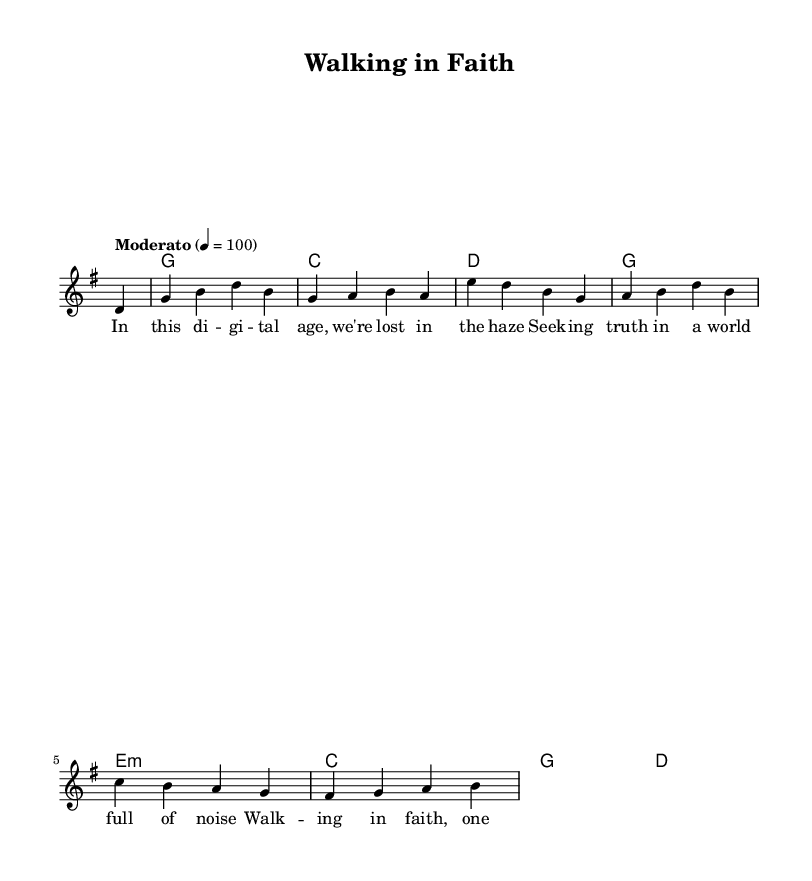What is the key signature of this music? The key signature is G major, which has one sharp (F#).
Answer: G major What is the time signature of this music? The time signature is 4/4, indicating four beats per measure.
Answer: 4/4 What is the tempo marking of this piece? The tempo marking is "Moderato," which typically means moderate speed, around 100 beats per minute.
Answer: Moderato How many measures are in the melody section? The melody section contains eight measures as indicated by the number of bar lines.
Answer: Eight What is the first chord in the score? The first chord in the score is G major, which is established right at the beginning of the harmonies.
Answer: G major What lyrical theme is addressed in this piece? The lyrical theme focuses on navigating faith in the context of modern challenges and distractions.
Answer: Faith in modern challenges What characteristic of blues is reflected in this music? The use of a call-and-response structure is a common characteristic of blues, represented by alternating lyrical phrases.
Answer: Call-and-response 